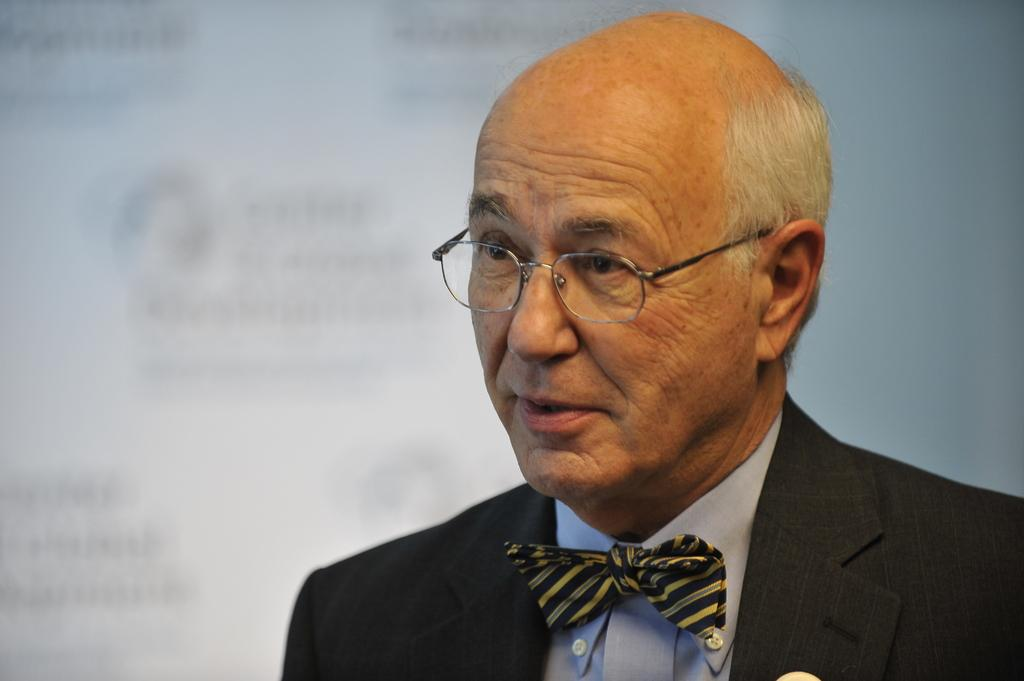What is the appearance of the person on the right side of the image? The person is in a suit and is wearing a spectacle. What is the person doing in the image? The person is speaking. What can be seen in the background of the image? There is a screen and a white wall in the background. How many horses are present in the image? There are no horses present in the image. Is the person in the image making a payment? There is no indication of payment being made in the image. 